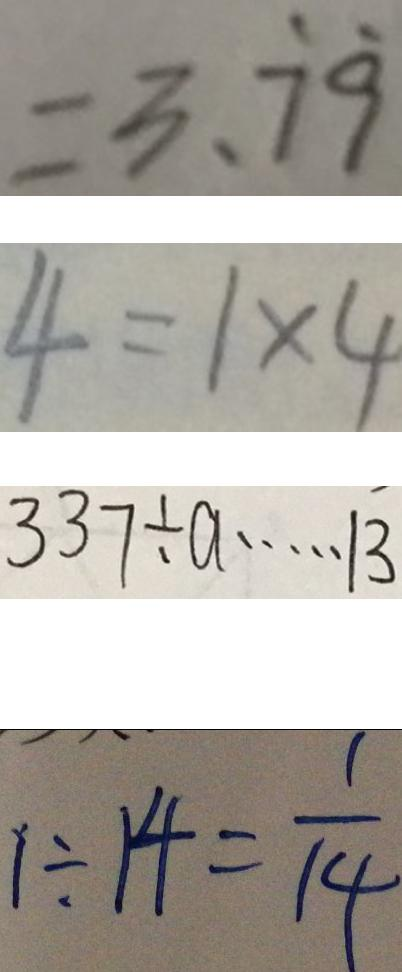<formula> <loc_0><loc_0><loc_500><loc_500>= 3 . \dot { 7 } \dot { 9 } 
 4 = 1 \times 4 
 3 3 7 \div a \cdots 1 3 
 1 \div 1 4 = \frac { 1 } { 1 4 }</formula> 